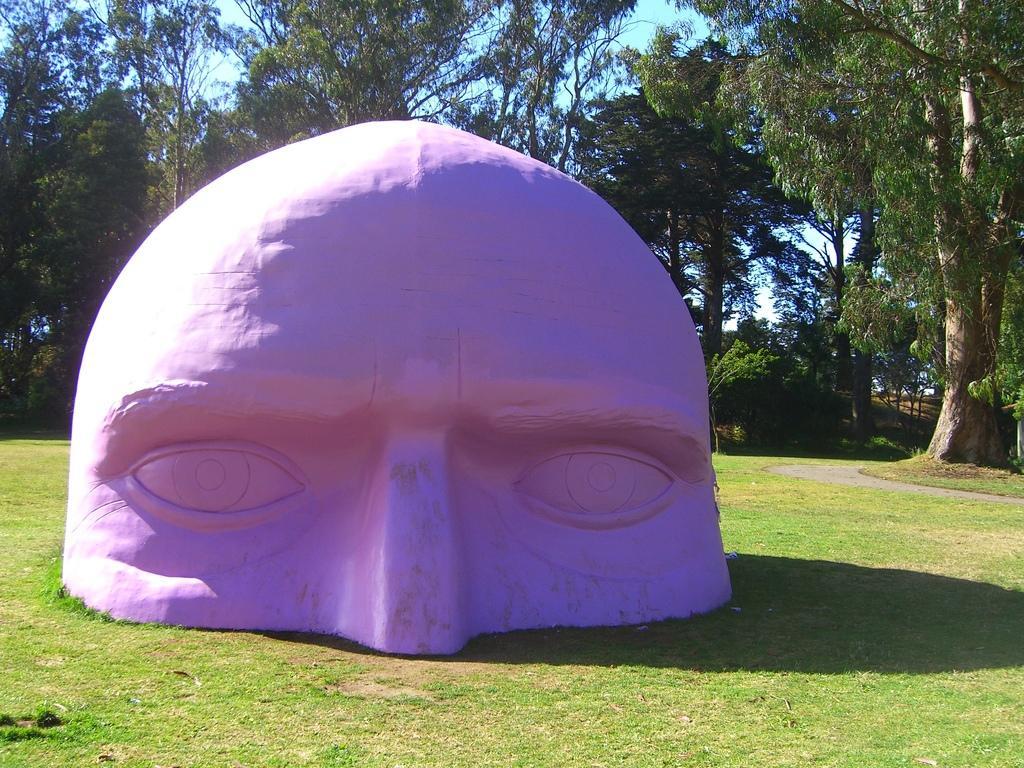Describe this image in one or two sentences. In this image I can see few trees and the sky. In front I can see the purple color object. 